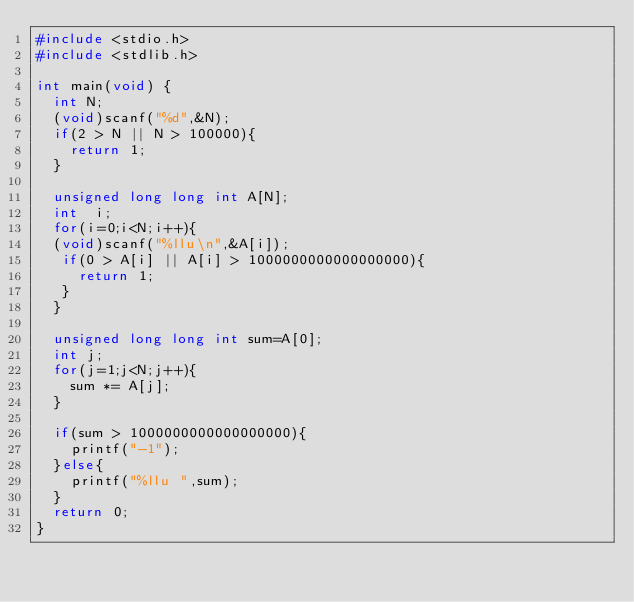Convert code to text. <code><loc_0><loc_0><loc_500><loc_500><_C_>#include <stdio.h>
#include <stdlib.h>

int main(void) {
	int N;
	(void)scanf("%d",&N);
	if(2 > N || N > 100000){
		return 1;
	}

	unsigned long long int A[N];
	int	 i;
	for(i=0;i<N;i++){
	(void)scanf("%llu\n",&A[i]);
	 if(0 > A[i] || A[i] > 1000000000000000000){
		 return 1;
	 }
	}

	unsigned long long int sum=A[0];
	int j;
	for(j=1;j<N;j++){
		sum *= A[j];
	}

	if(sum > 1000000000000000000){
		printf("-1");
	}else{
		printf("%llu ",sum);
	}
	return 0;
}
</code> 